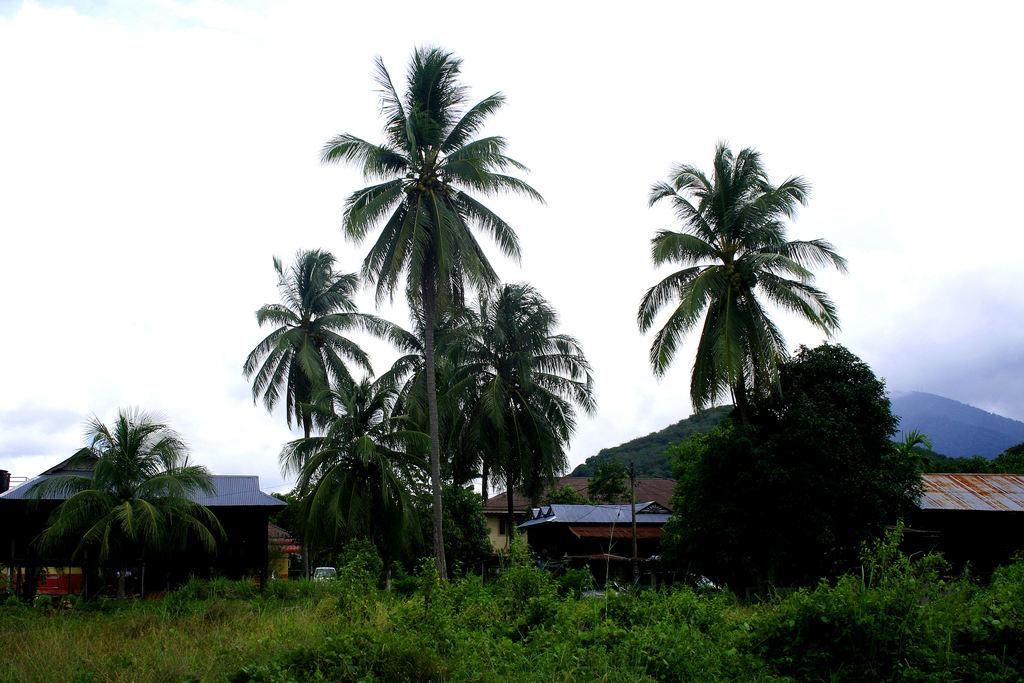What type of landscape is depicted in the image? The image features hills. What type of structures can be seen in the image? There are houses in the image. What type of vegetation is present in the image? There are many trees and plants in the image. What type of transportation is visible in the image? There is a vehicle in the image. What is the condition of the sky in the image? The sky is cloudy in the image. What type of trousers are the trees wearing in the image? Trees do not wear trousers, as they are plants and not human beings. 